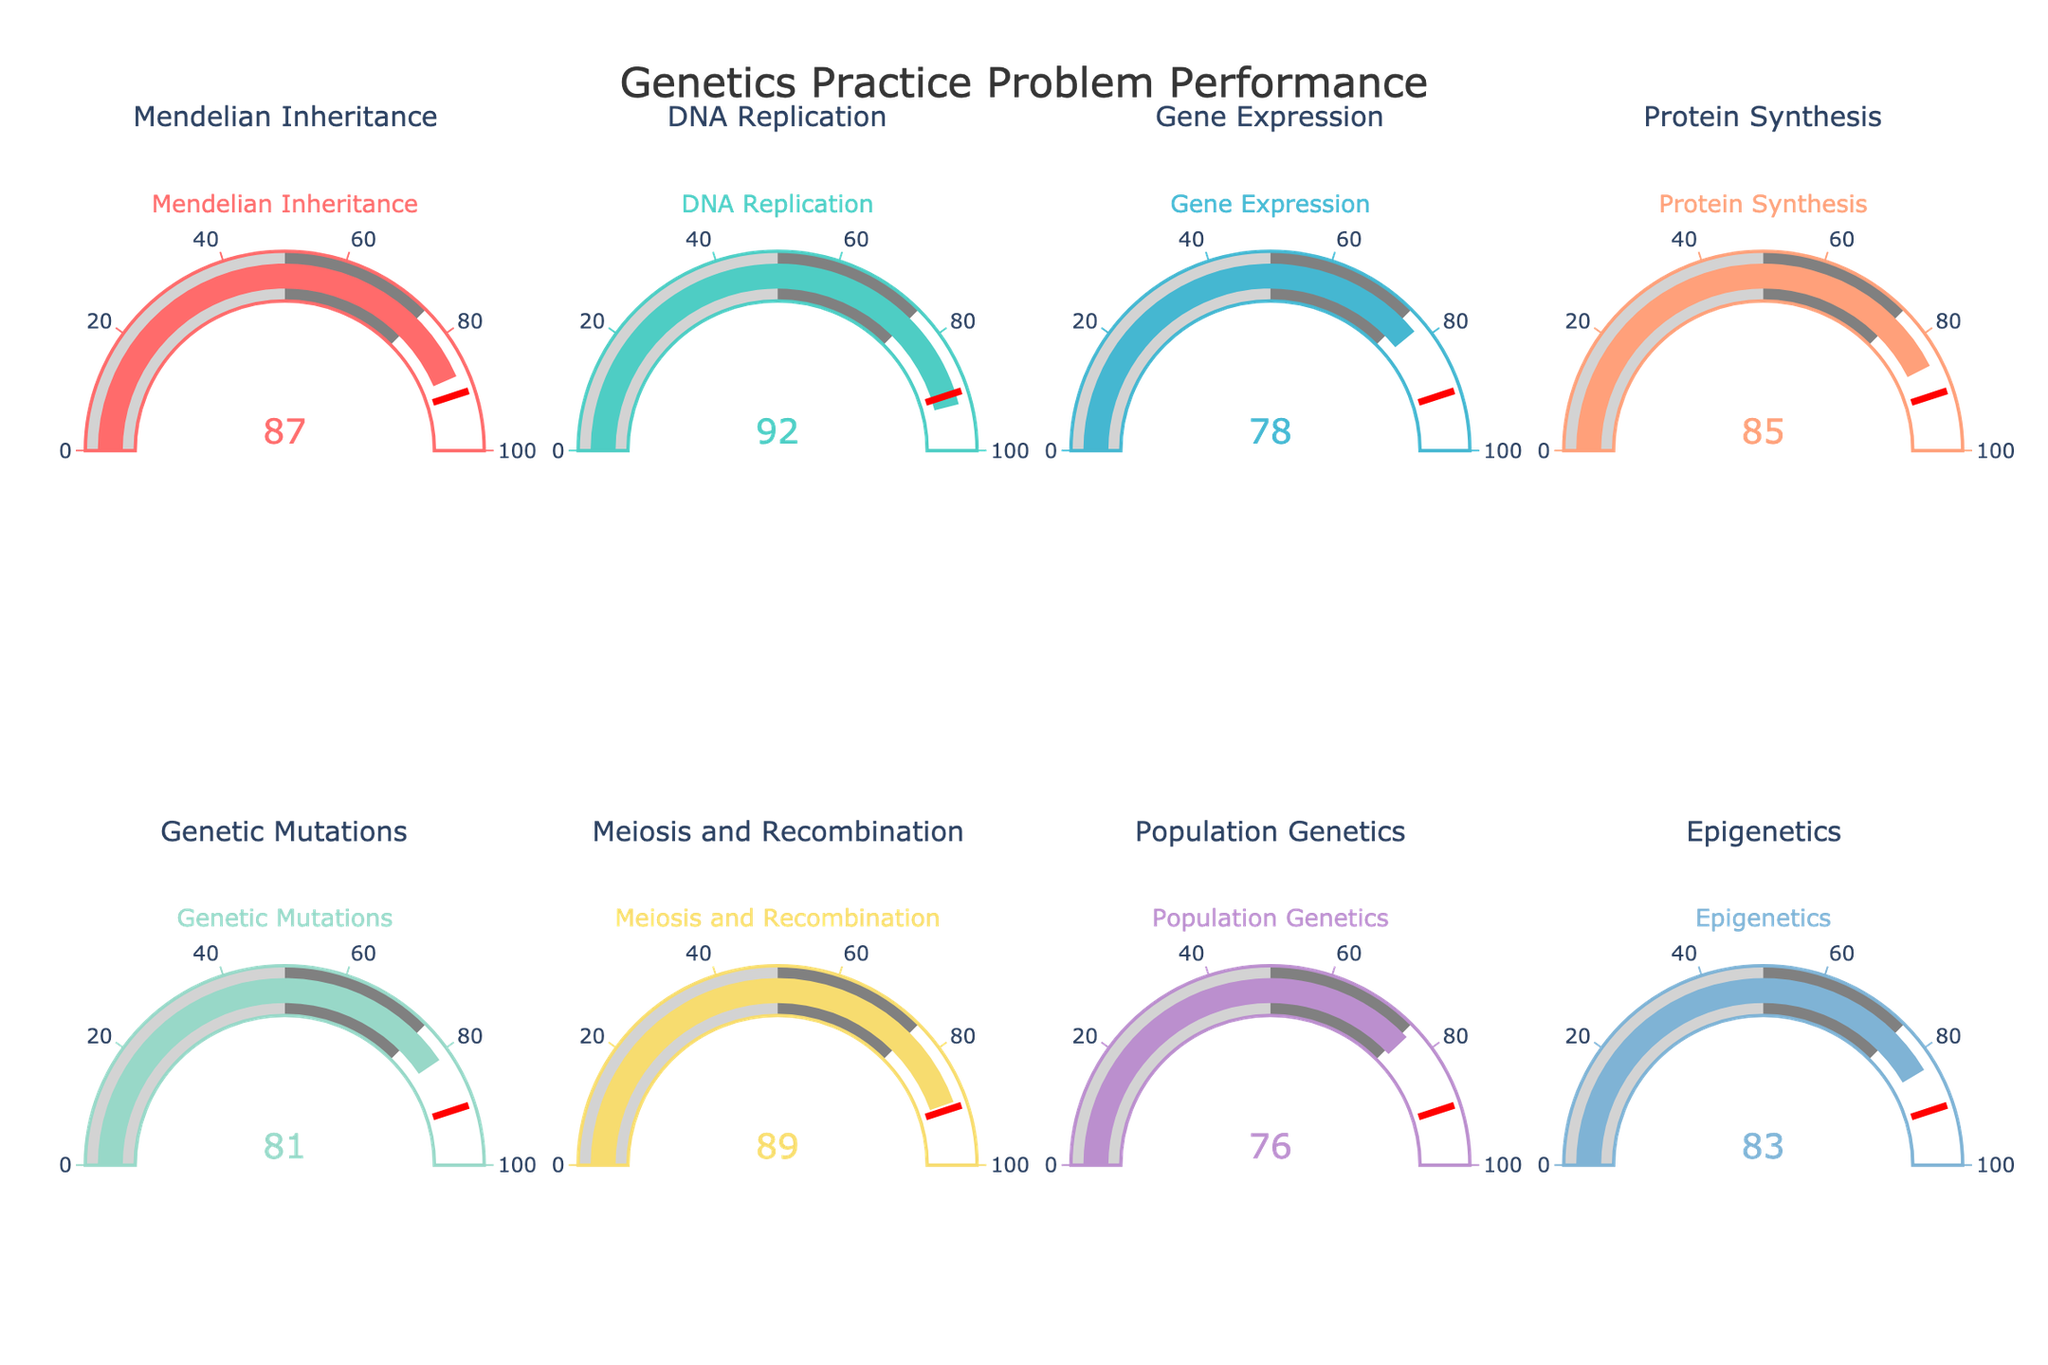Which category has the highest percentage of correctly solved practice problems? The figure shows various categories with different percentages. The highest percentage is the one closest to 100. Check each gauge and locate the one with the highest value.
Answer: DNA Replication What is the percentage of correctly solved practice problems for Gene Expression? Look for the gauge labeled "Gene Expression" and read the percentage value displayed.
Answer: 78 Compare the percentages of Genetic Mutations and Epigenetics. Which one is higher? Identify the gauges for Genetic Mutations and Epigenetics, then compare their values to see which is greater.
Answer: Epigenetics What is the average percentage of correctly solved practice problems for Mendelian Inheritance, DNA Replication, and Gene Expression? First, sum the percentages for these three categories: 87 (Mendelian Inheritance) + 92 (DNA Replication) + 78 (Gene Expression). Then, divide by 3 to find the average.
Answer: 85.67 How many categories have a percentage of correctly solved practice problems above 80%? Count the number of gauges where the percentage value is greater than 80. Sort through each gauge and count accordingly.
Answer: 6 What is the median value of the percentages across all categories? List out all the percentages: 87, 92, 78, 85, 81, 89, 76, and 83. Arrange them in numerical order: 76, 78, 81, 83, 85, 87, 89, 92. The median is the middle value, or the average of the two middle values. Since we have 8 values, average the 4th and 5th values: 83 and 85. The median is (83 + 85) / 2.
Answer: 84 Which category has the lowest percentage of correctly solved practice problems? Locate the gauge with the smallest value displayed.
Answer: Population Genetics What is the difference in percentage between the categories with the highest and lowest performance? Identify the highest (DNA Replication, 92) and lowest (Population Genetics, 76) percentages. Calculate the difference: 92 - 76.
Answer: 16 How does the value on the gauge for Protein Synthesis compare to the threshold of 90? Check the percentage displayed for Protein Synthesis (85) and compare it to the threshold value of 90.
Answer: Below What percentage is displayed for Meiosis and Recombination? Locate the gauge labeled "Meiosis and Recombination" and read the percentage value displayed.
Answer: 89 